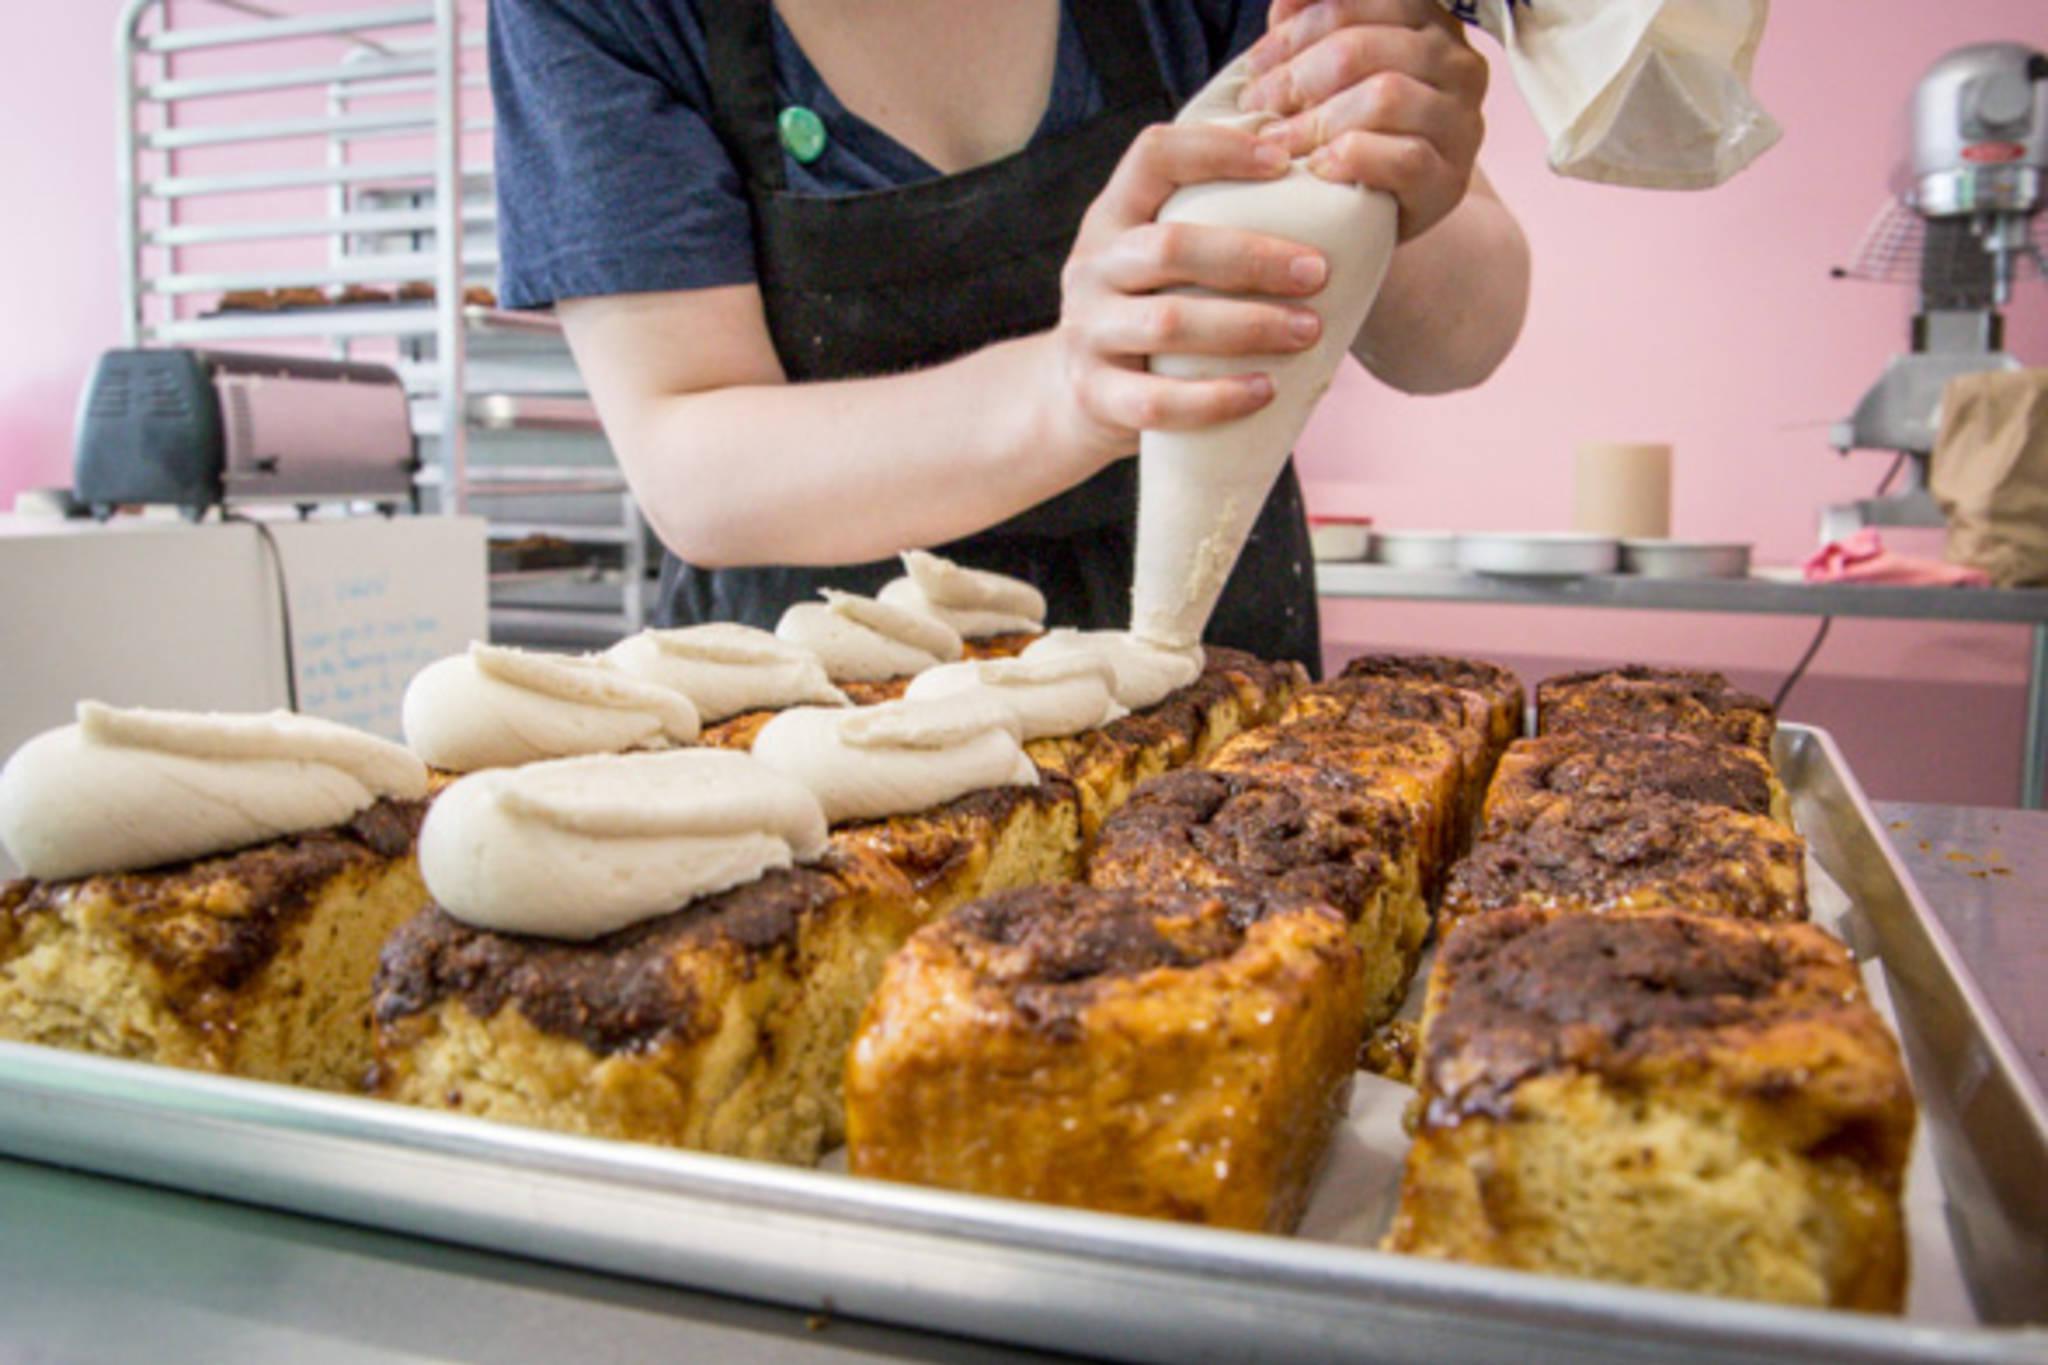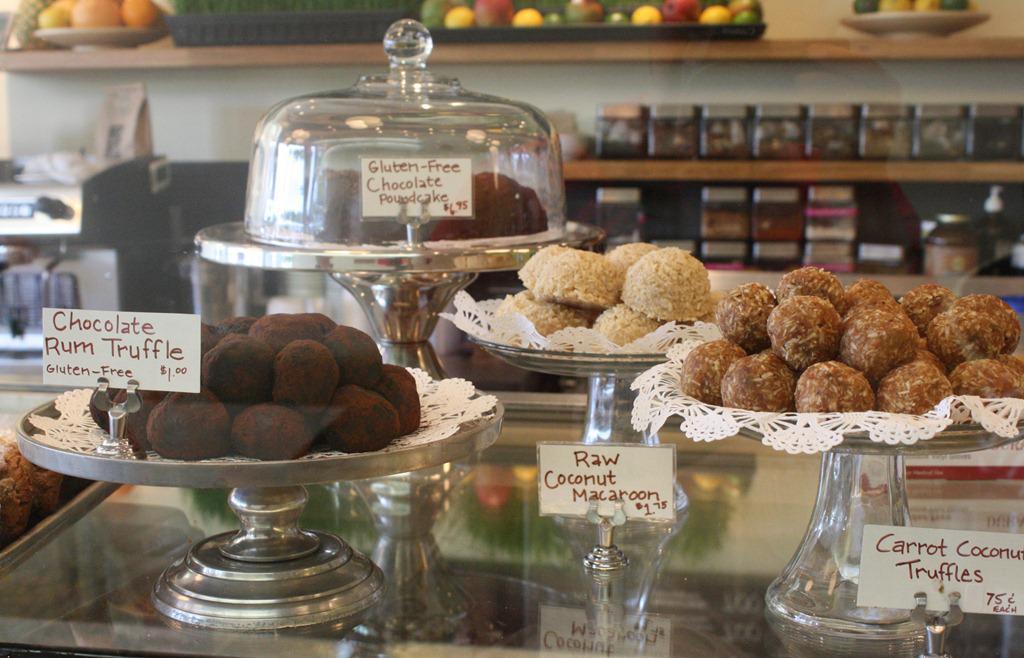The first image is the image on the left, the second image is the image on the right. Analyze the images presented: Is the assertion "In the image to the right, you can see the customers." valid? Answer yes or no. No. The first image is the image on the left, the second image is the image on the right. For the images displayed, is the sentence "An image shows two people standing upright a distance apart in front of a counter with a light wood front and a top filled with containers of baked treats marked with cards." factually correct? Answer yes or no. No. 